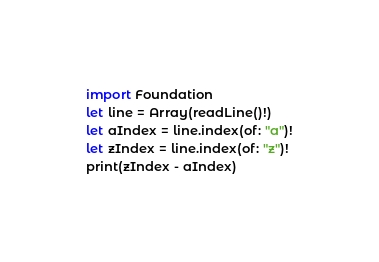Convert code to text. <code><loc_0><loc_0><loc_500><loc_500><_Swift_>import Foundation
let line = Array(readLine()!)
let aIndex = line.index(of: "a")!
let zIndex = line.index(of: "z")!
print(zIndex - aIndex)</code> 